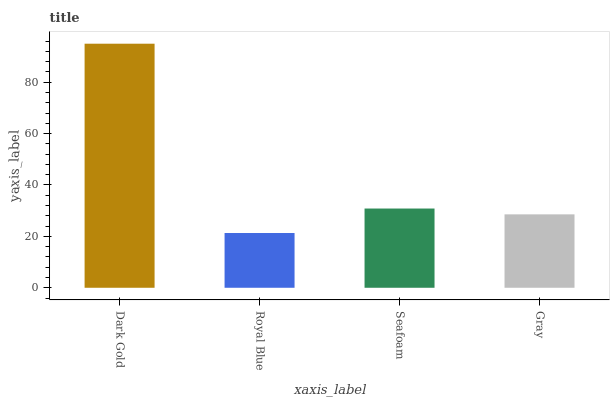Is Royal Blue the minimum?
Answer yes or no. Yes. Is Dark Gold the maximum?
Answer yes or no. Yes. Is Seafoam the minimum?
Answer yes or no. No. Is Seafoam the maximum?
Answer yes or no. No. Is Seafoam greater than Royal Blue?
Answer yes or no. Yes. Is Royal Blue less than Seafoam?
Answer yes or no. Yes. Is Royal Blue greater than Seafoam?
Answer yes or no. No. Is Seafoam less than Royal Blue?
Answer yes or no. No. Is Seafoam the high median?
Answer yes or no. Yes. Is Gray the low median?
Answer yes or no. Yes. Is Dark Gold the high median?
Answer yes or no. No. Is Seafoam the low median?
Answer yes or no. No. 